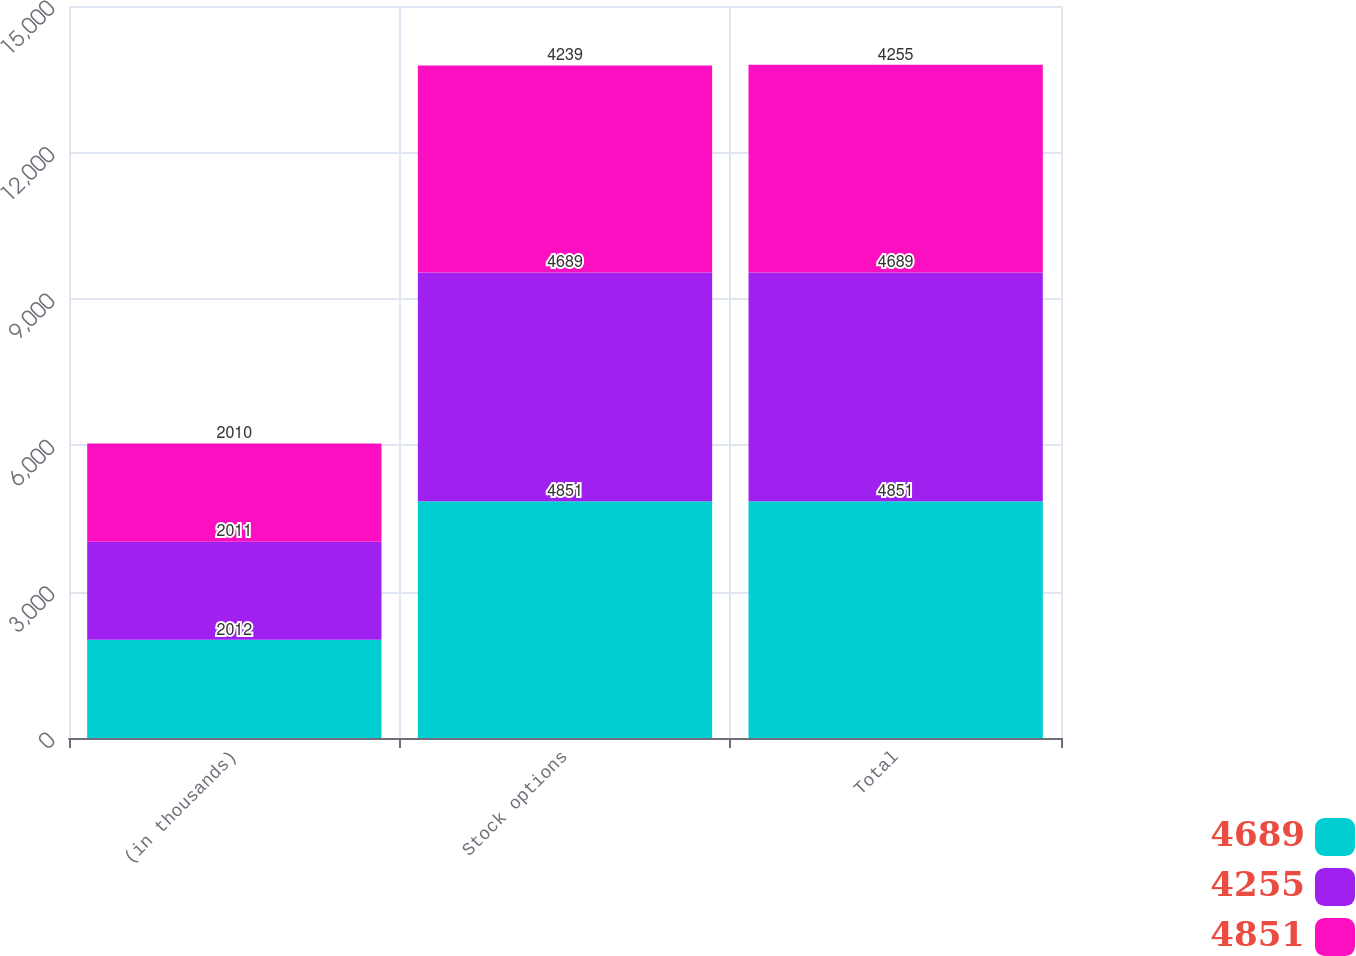Convert chart. <chart><loc_0><loc_0><loc_500><loc_500><stacked_bar_chart><ecel><fcel>(in thousands)<fcel>Stock options<fcel>Total<nl><fcel>4689<fcel>2012<fcel>4851<fcel>4851<nl><fcel>4255<fcel>2011<fcel>4689<fcel>4689<nl><fcel>4851<fcel>2010<fcel>4239<fcel>4255<nl></chart> 